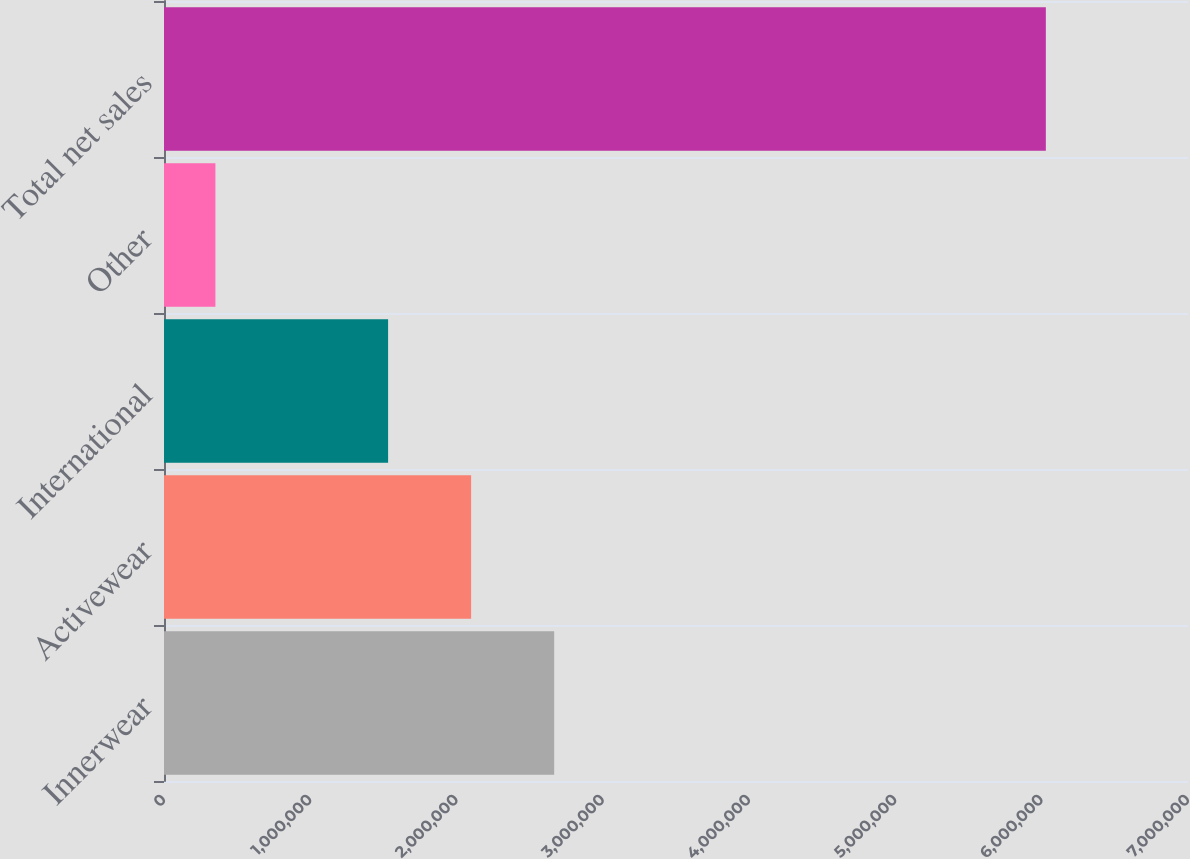<chart> <loc_0><loc_0><loc_500><loc_500><bar_chart><fcel>Innerwear<fcel>Activewear<fcel>International<fcel>Other<fcel>Total net sales<nl><fcel>2.66726e+06<fcel>2.09959e+06<fcel>1.53191e+06<fcel>351461<fcel>6.0282e+06<nl></chart> 